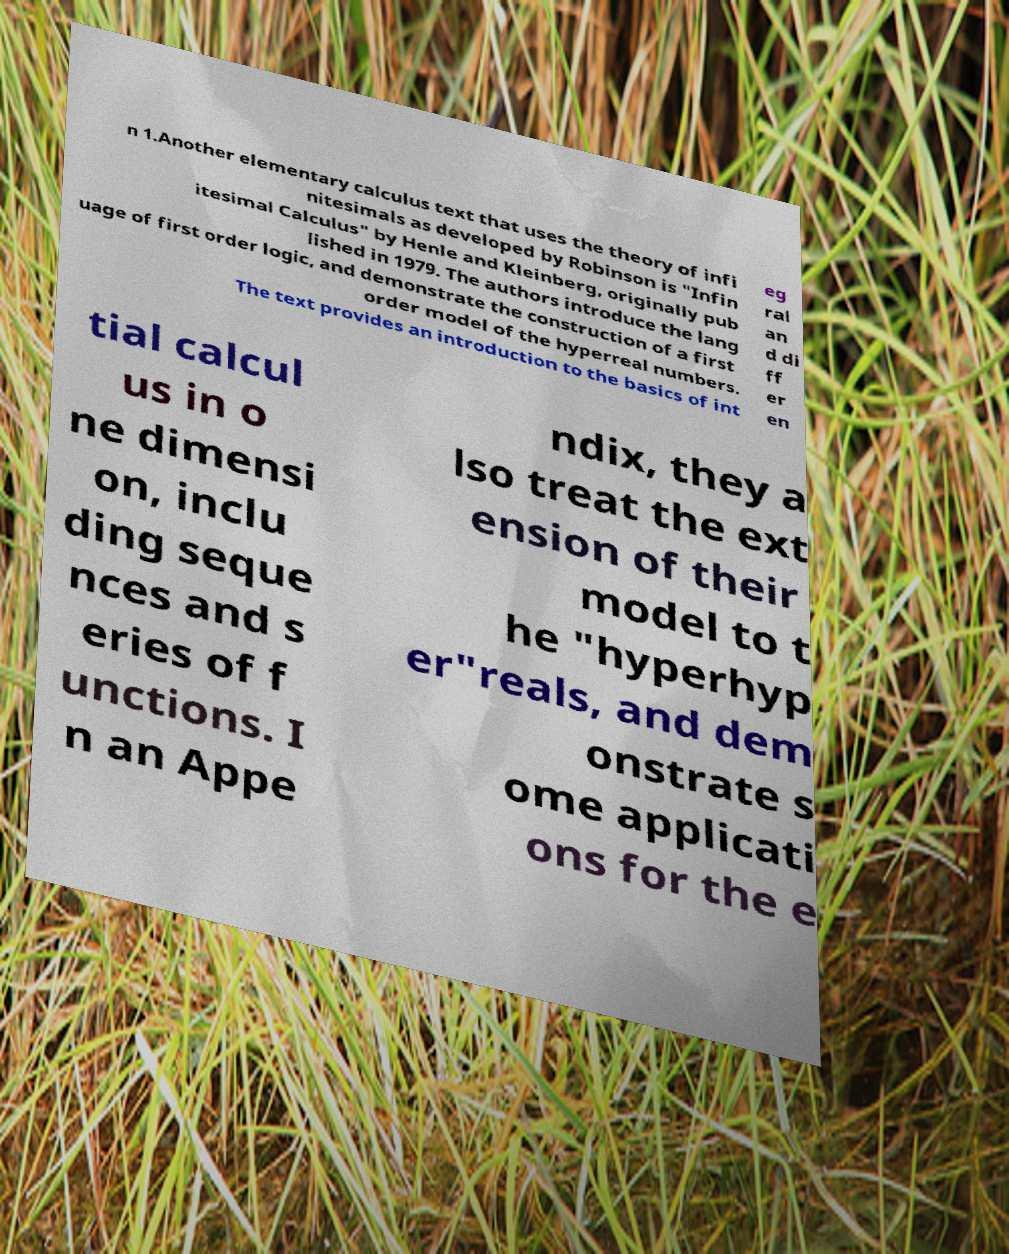Please read and relay the text visible in this image. What does it say? n 1.Another elementary calculus text that uses the theory of infi nitesimals as developed by Robinson is "Infin itesimal Calculus" by Henle and Kleinberg, originally pub lished in 1979. The authors introduce the lang uage of first order logic, and demonstrate the construction of a first order model of the hyperreal numbers. The text provides an introduction to the basics of int eg ral an d di ff er en tial calcul us in o ne dimensi on, inclu ding seque nces and s eries of f unctions. I n an Appe ndix, they a lso treat the ext ension of their model to t he "hyperhyp er"reals, and dem onstrate s ome applicati ons for the e 